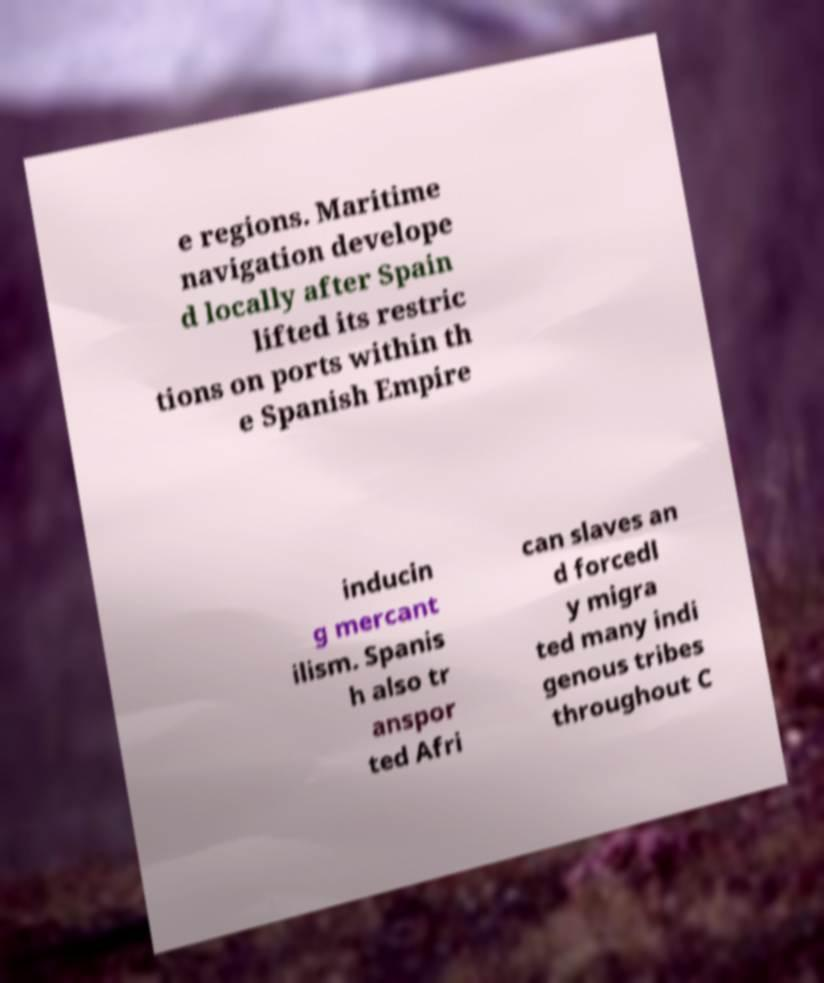Can you accurately transcribe the text from the provided image for me? e regions. Maritime navigation develope d locally after Spain lifted its restric tions on ports within th e Spanish Empire inducin g mercant ilism. Spanis h also tr anspor ted Afri can slaves an d forcedl y migra ted many indi genous tribes throughout C 